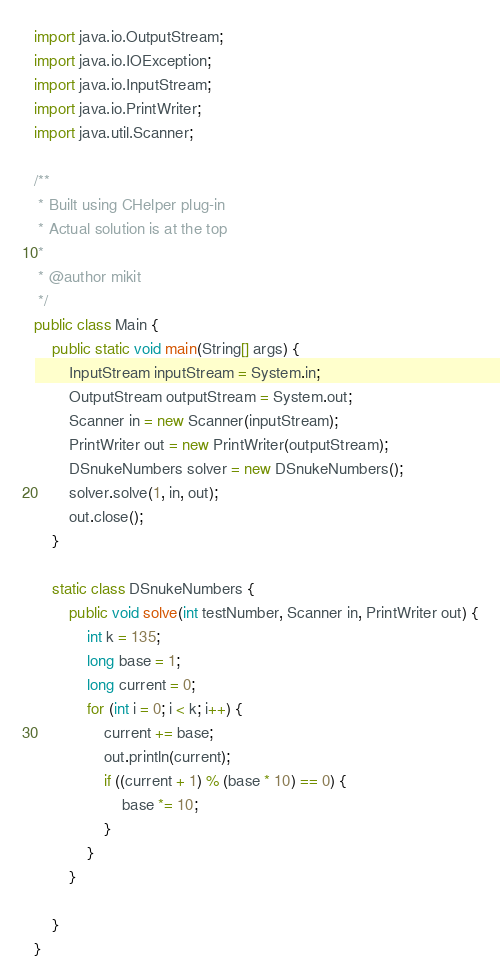<code> <loc_0><loc_0><loc_500><loc_500><_Java_>import java.io.OutputStream;
import java.io.IOException;
import java.io.InputStream;
import java.io.PrintWriter;
import java.util.Scanner;

/**
 * Built using CHelper plug-in
 * Actual solution is at the top
 *
 * @author mikit
 */
public class Main {
    public static void main(String[] args) {
        InputStream inputStream = System.in;
        OutputStream outputStream = System.out;
        Scanner in = new Scanner(inputStream);
        PrintWriter out = new PrintWriter(outputStream);
        DSnukeNumbers solver = new DSnukeNumbers();
        solver.solve(1, in, out);
        out.close();
    }

    static class DSnukeNumbers {
        public void solve(int testNumber, Scanner in, PrintWriter out) {
            int k = 135;
            long base = 1;
            long current = 0;
            for (int i = 0; i < k; i++) {
                current += base;
                out.println(current);
                if ((current + 1) % (base * 10) == 0) {
                    base *= 10;
                }
            }
        }

    }
}

</code> 